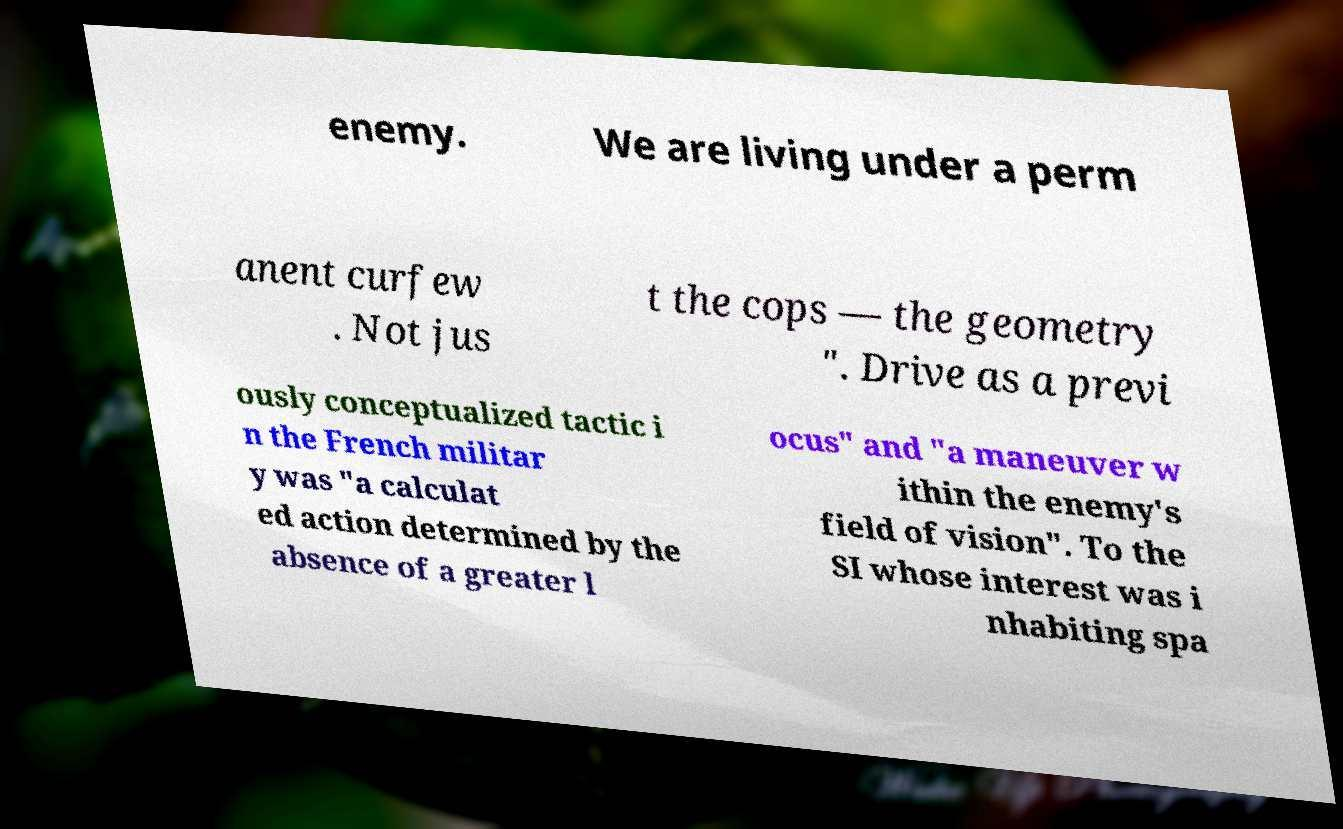What messages or text are displayed in this image? I need them in a readable, typed format. enemy. We are living under a perm anent curfew . Not jus t the cops — the geometry ". Drive as a previ ously conceptualized tactic i n the French militar y was "a calculat ed action determined by the absence of a greater l ocus" and "a maneuver w ithin the enemy's field of vision". To the SI whose interest was i nhabiting spa 